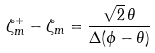<formula> <loc_0><loc_0><loc_500><loc_500>\zeta _ { m } ^ { + } - \zeta _ { m } = \frac { \sqrt { 2 } \, \theta } { \Delta ( \phi - \theta ) }</formula> 